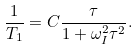Convert formula to latex. <formula><loc_0><loc_0><loc_500><loc_500>\frac { 1 } { T _ { 1 } } = C \frac { \tau } { 1 + \omega ^ { 2 } _ { I } \tau ^ { 2 } } .</formula> 